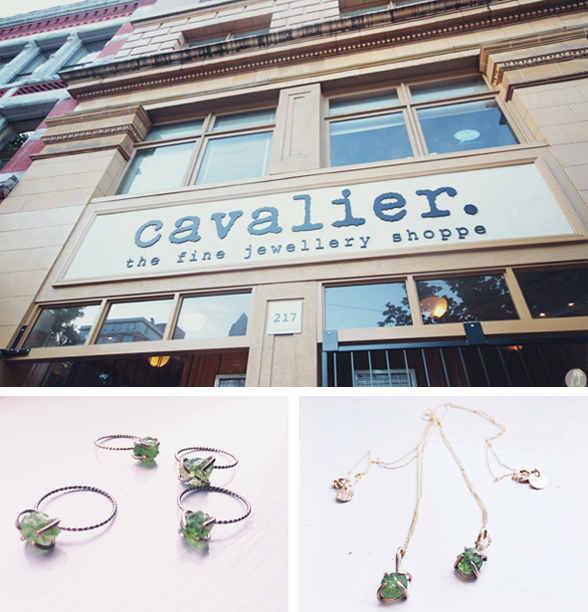How does the design of the rings in the image reflect current trends in jewelry design? The design of the rings in the image suggests a blend of classic and modern elements. The thick bands paired with the oversized, faceted green gemstones align with a current trend towards statement jewelry that showcases prominent, eye-catching elements. This style suits consumers looking for distinctive, fashionable pieces that stand out while still retaining a sense of timelessness. Can these types of designs be versatile for everyday wear? While the rings feature bold and substantial gemstones, their clean lines and the absence of excessive ornamental detailing make them surprisingly versatile. They can be dressed up for special occasions or paired down for a more casual, everyday look, offering both style and functionality to the modern consumer. 